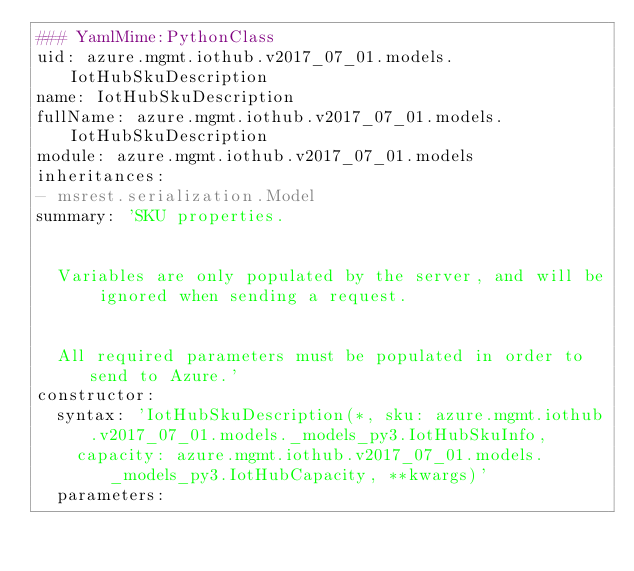<code> <loc_0><loc_0><loc_500><loc_500><_YAML_>### YamlMime:PythonClass
uid: azure.mgmt.iothub.v2017_07_01.models.IotHubSkuDescription
name: IotHubSkuDescription
fullName: azure.mgmt.iothub.v2017_07_01.models.IotHubSkuDescription
module: azure.mgmt.iothub.v2017_07_01.models
inheritances:
- msrest.serialization.Model
summary: 'SKU properties.


  Variables are only populated by the server, and will be ignored when sending a request.


  All required parameters must be populated in order to send to Azure.'
constructor:
  syntax: 'IotHubSkuDescription(*, sku: azure.mgmt.iothub.v2017_07_01.models._models_py3.IotHubSkuInfo,
    capacity: azure.mgmt.iothub.v2017_07_01.models._models_py3.IotHubCapacity, **kwargs)'
  parameters:</code> 